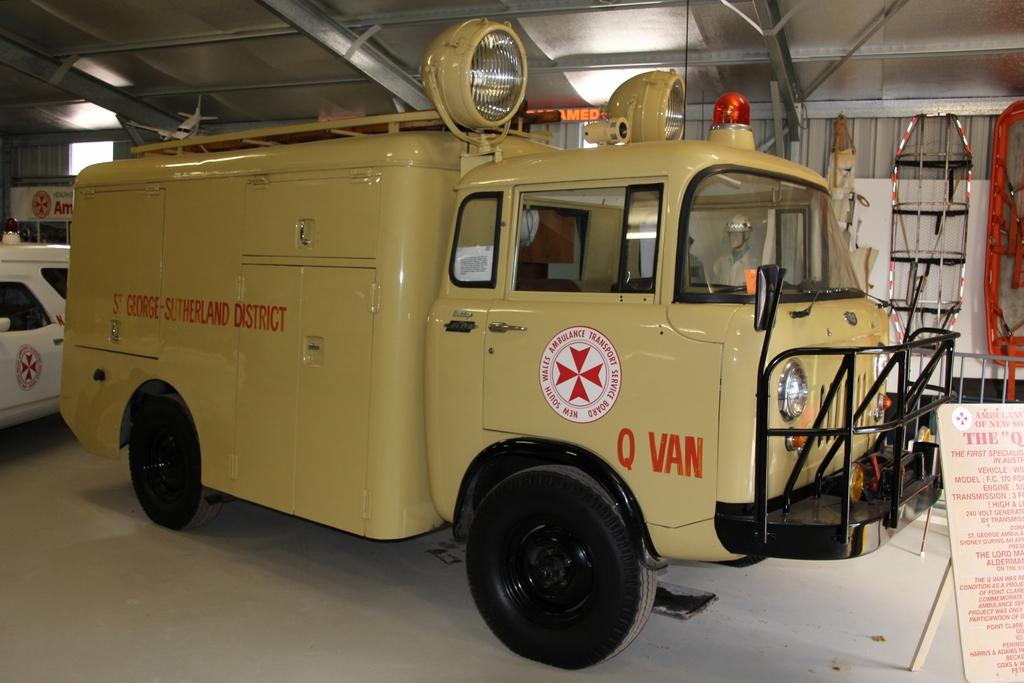What type of vehicle is in the image? The image contains a van. What are the headlights used for on the van? The headlights are used for illuminating the road when it's dark. What is the color of the light on top of the van? There is an orange color light on top of the van. What is on the right side of the van? There is a board on the right side of the van. What is the color of the matter on the board? The matter on the board is in red color. What hobbies does the van enjoy in the image? Vans do not have hobbies, as they are inanimate objects. What fact can be learned about the board on the right side of the van? The fact that the matter on the board is in red color is already mentioned in the conversation. 